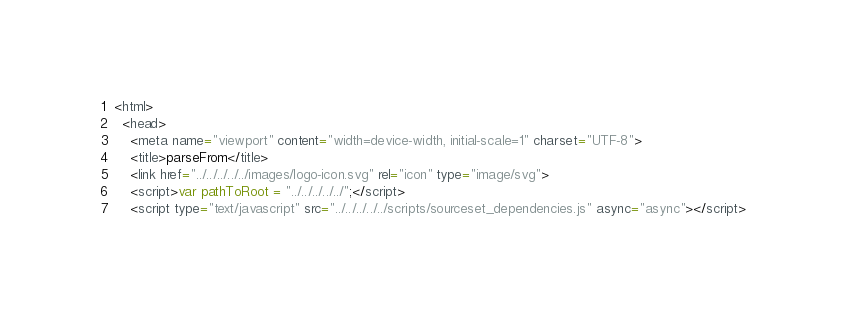<code> <loc_0><loc_0><loc_500><loc_500><_HTML_><html>
  <head>
    <meta name="viewport" content="width=device-width, initial-scale=1" charset="UTF-8">
    <title>parseFrom</title>
    <link href="../../../../../images/logo-icon.svg" rel="icon" type="image/svg">
    <script>var pathToRoot = "../../../../../";</script>
    <script type="text/javascript" src="../../../../../scripts/sourceset_dependencies.js" async="async"></script></code> 